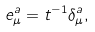Convert formula to latex. <formula><loc_0><loc_0><loc_500><loc_500>e ^ { a } _ { \mu } = t ^ { - 1 } \delta ^ { a } _ { \mu } ,</formula> 